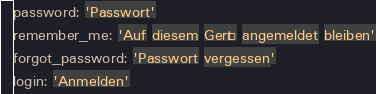Convert code to text. <code><loc_0><loc_0><loc_500><loc_500><_YAML_>password: 'Passwort'
remember_me: 'Auf diesem Gerät angemeldet bleiben'
forgot_password: 'Passwort vergessen'
login: 'Anmelden'
</code> 